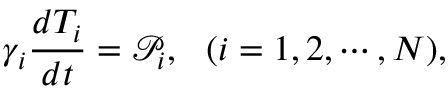<formula> <loc_0><loc_0><loc_500><loc_500>\gamma _ { i } \frac { d T _ { i } } { d t } = \mathcal { P } _ { i } , ( i = 1 , 2 , \cdots , N ) ,</formula> 